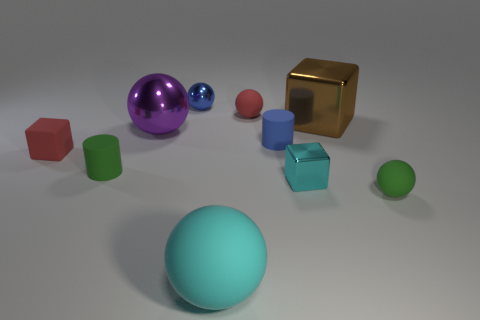There is a blue object in front of the blue ball; is it the same size as the tiny matte block?
Offer a terse response. Yes. What number of large objects are green things or cyan balls?
Provide a short and direct response. 1. Is there a large ball of the same color as the large metal cube?
Offer a very short reply. No. What shape is the cyan object that is the same size as the purple metal ball?
Offer a very short reply. Sphere. There is a matte cylinder that is on the right side of the purple object; does it have the same color as the tiny metal cube?
Provide a short and direct response. No. What number of objects are either shiny balls in front of the big brown thing or purple shiny balls?
Offer a terse response. 1. Are there more rubber things on the right side of the green sphere than cyan objects right of the cyan rubber ball?
Your response must be concise. No. Is the material of the brown object the same as the red sphere?
Ensure brevity in your answer.  No. There is a thing that is both right of the purple shiny sphere and left of the big cyan sphere; what is its shape?
Your answer should be very brief. Sphere. There is a brown thing that is the same material as the small cyan block; what is its shape?
Your response must be concise. Cube. 